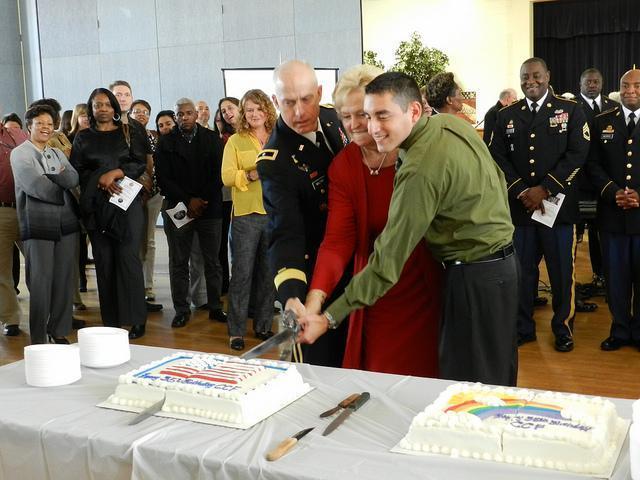How many sheet cakes are shown?
Give a very brief answer. 2. How many people can be seen?
Give a very brief answer. 10. How many cakes are there?
Give a very brief answer. 2. How many buses are behind a street sign?
Give a very brief answer. 0. 